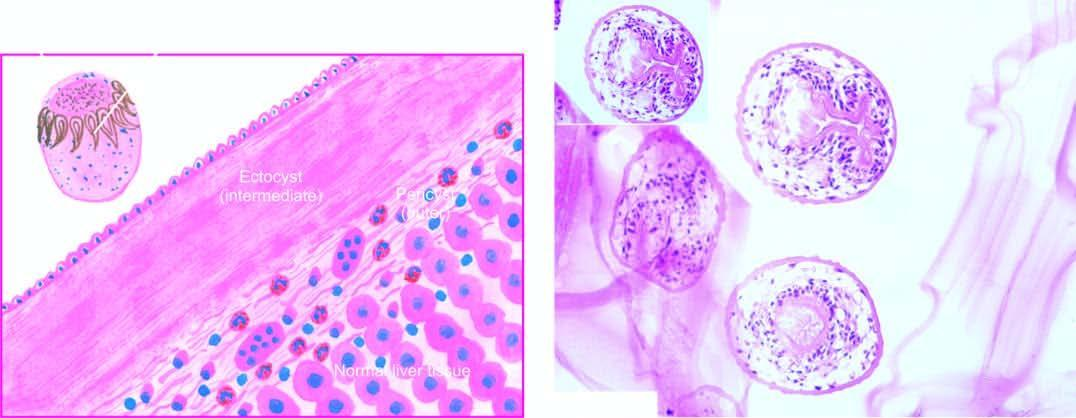what shows a scolex with a row of hooklets?
Answer the question using a single word or phrase. Inbox in the right photomicrograph 